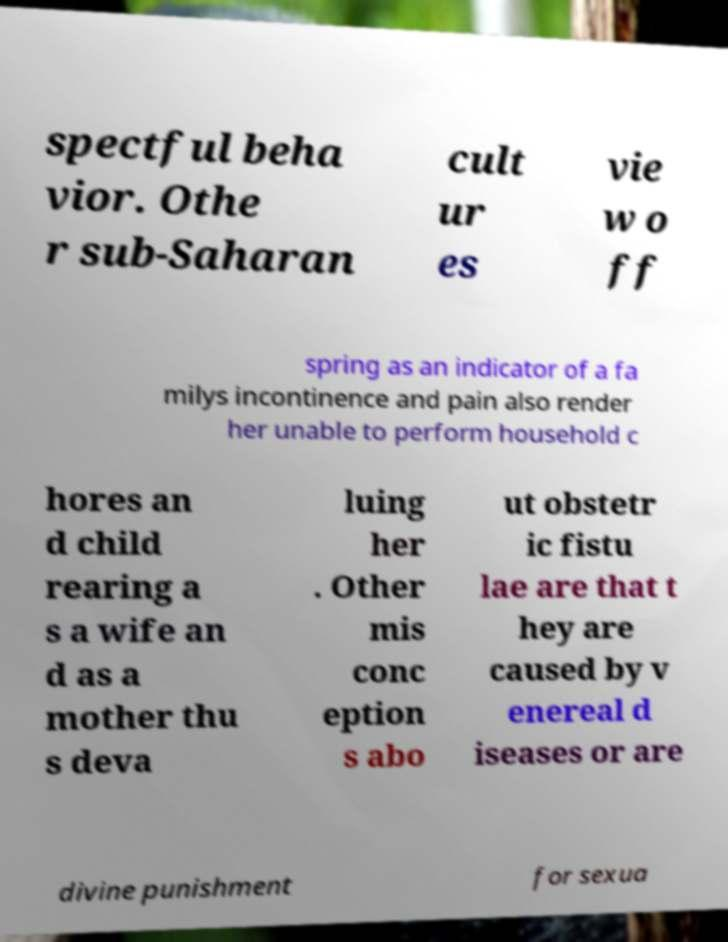Could you assist in decoding the text presented in this image and type it out clearly? spectful beha vior. Othe r sub-Saharan cult ur es vie w o ff spring as an indicator of a fa milys incontinence and pain also render her unable to perform household c hores an d child rearing a s a wife an d as a mother thu s deva luing her . Other mis conc eption s abo ut obstetr ic fistu lae are that t hey are caused by v enereal d iseases or are divine punishment for sexua 